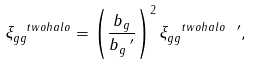Convert formula to latex. <formula><loc_0><loc_0><loc_500><loc_500>\xi _ { g g } ^ { \ t w o h a l o } = \left ( \frac { b _ { g } } { b _ { g } ^ { \ \prime } } \right ) ^ { 2 } \xi _ { g g } ^ { \ t w o h a l o \ \prime } ,</formula> 